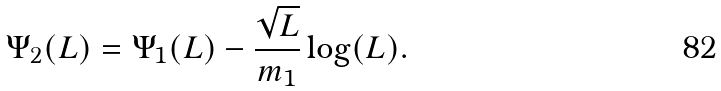Convert formula to latex. <formula><loc_0><loc_0><loc_500><loc_500>\Psi _ { 2 } ( L ) = \Psi _ { 1 } ( L ) - \frac { \sqrt { L } } { m _ { 1 } } \log ( L ) .</formula> 